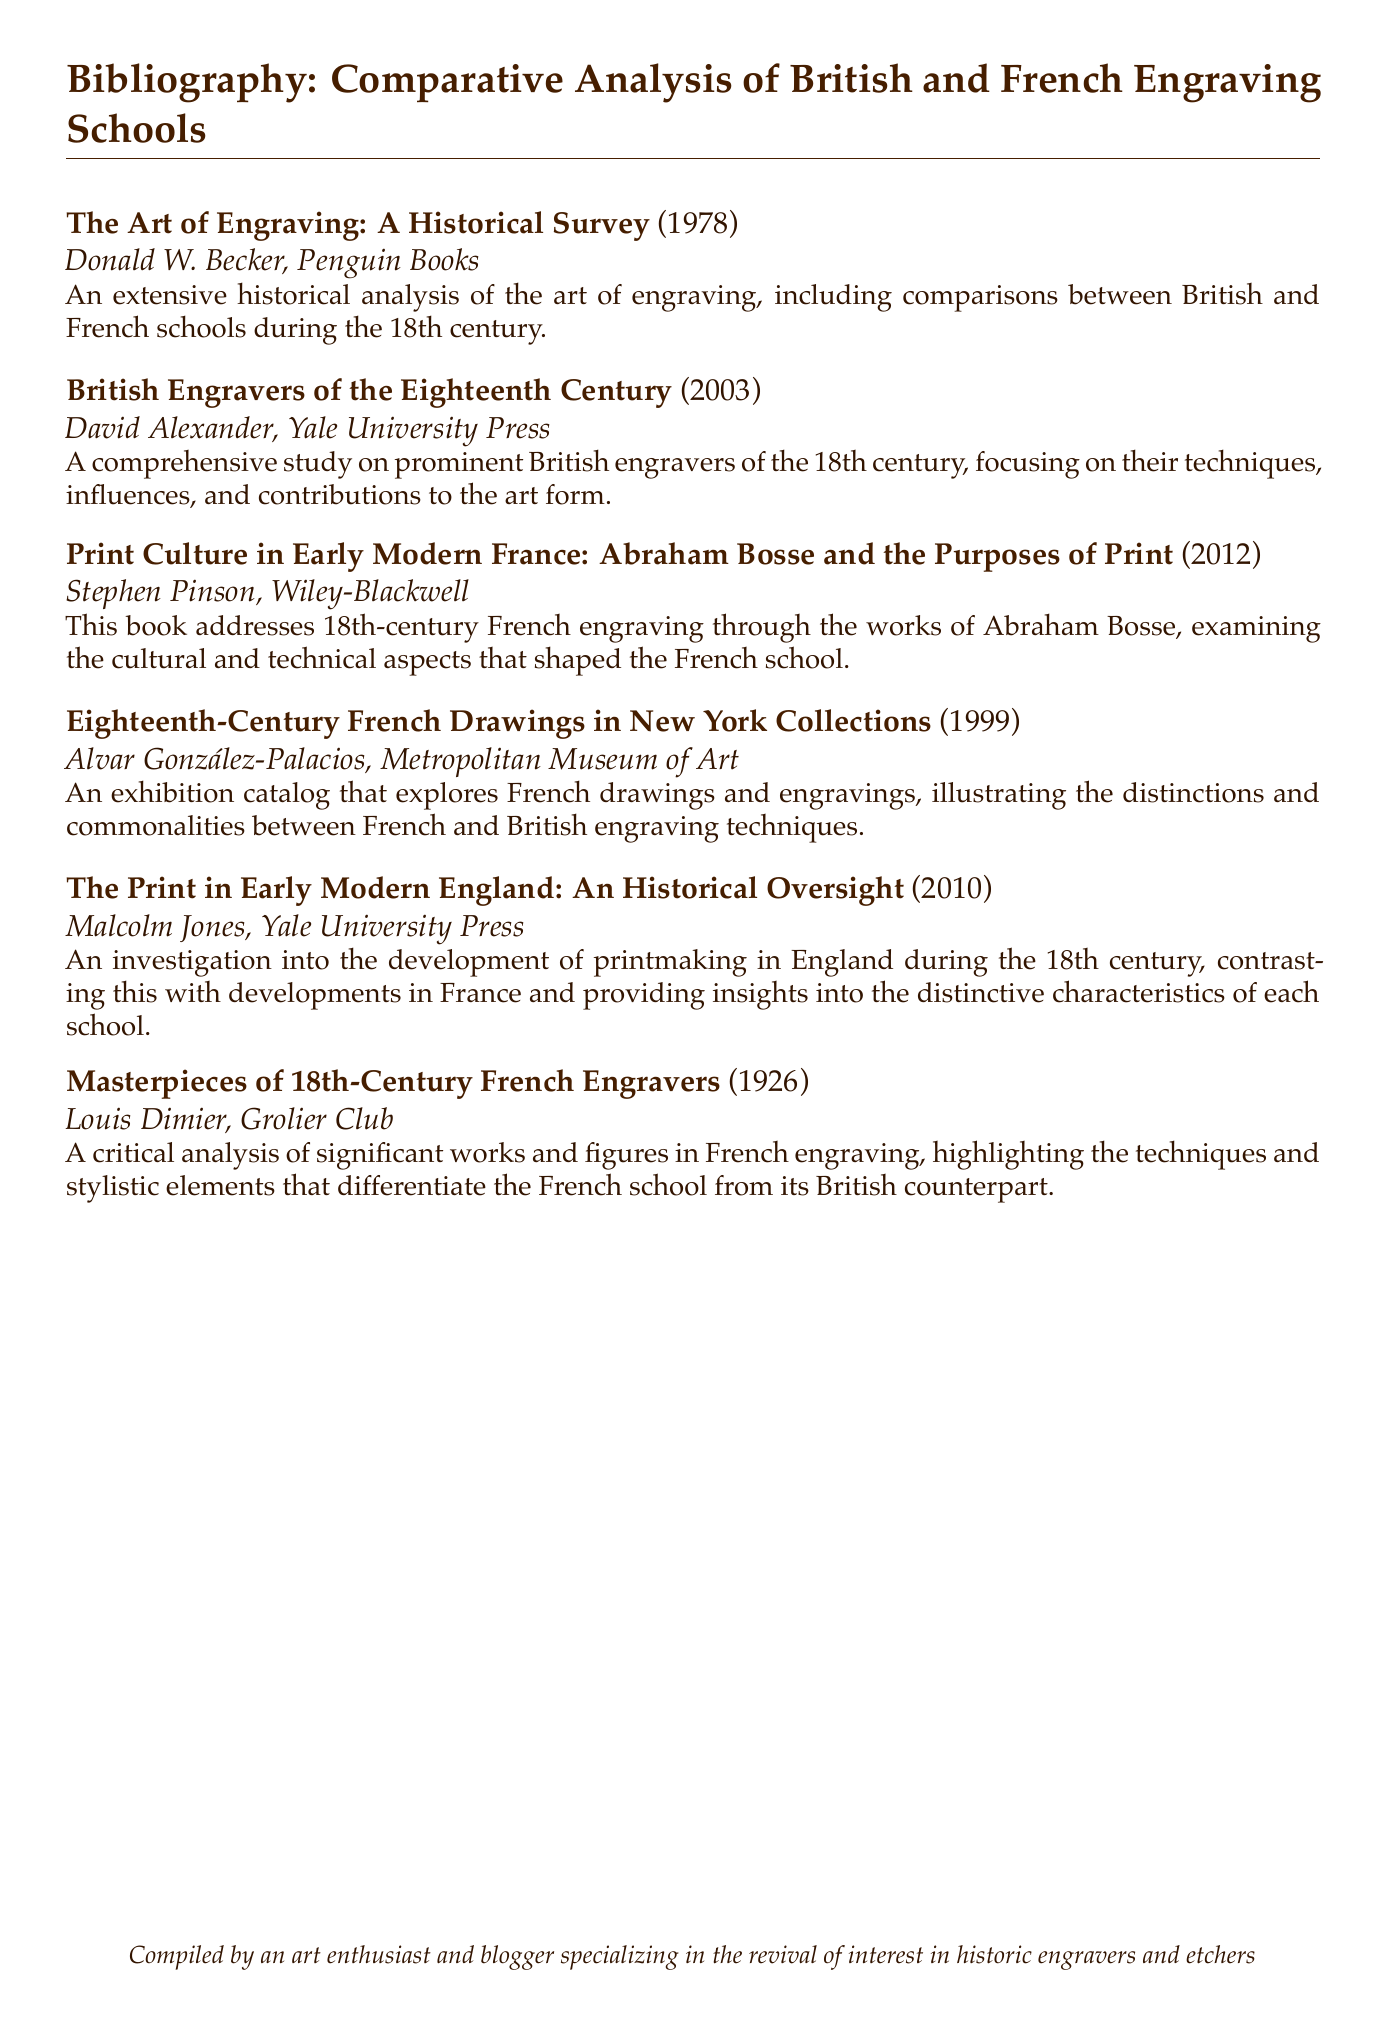What is the title of the first entry? The title of the first entry is the name of the book, which appears at the beginning of the bibentry.
Answer: The Art of Engraving: A Historical Survey Who is the author of the book published in 2003? The author is mentioned right after the title and year of publication in the bibentry format.
Answer: David Alexander In what year was "Masterpieces of 18th-Century French Engravers" published? The year of publication is stated in parentheses right after the title in the bibentry.
Answer: 1926 Which publisher released the book "Print Culture in Early Modern France"? The publisher is included at the end of the bibentry, following the author's name.
Answer: Wiley-Blackwell How many entries are listed in the bibliography? The total number of bibentry entries gives the number of items in the bibliography.
Answer: 6 What common theme do the entries in this bibliography share? Analyzing the entries reveals that they all focus on engraving techniques and schools within a specific historical context.
Answer: Engraving techniques What type of document is presented? The document type can be identified by its structure and the context of the entries listed.
Answer: Bibliography Which city is associated with the publisher of the 2003 book? The city of publication can often be noted with the publisher information but is missing in some entries, which limits this question's applicability.
Answer: New Haven (implicit; from Yale University Press) Name one of the key focuses mentioned in the entry about British Engravers of the Eighteenth Century. Each bibentry provides certain focal points regarding the content or analysis of the work discussed.
Answer: Techniques 